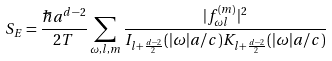<formula> <loc_0><loc_0><loc_500><loc_500>S _ { E } = \frac { \hbar { a } ^ { d - 2 } } { 2 T } \sum _ { \omega , l , m } \frac { | f _ { \omega l } ^ { ( m ) } | ^ { 2 } } { I _ { l + \frac { d - 2 } { 2 } } ( | \omega | a / c ) K _ { l + \frac { d - 2 } { 2 } } ( | \omega | a / c ) }</formula> 